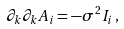<formula> <loc_0><loc_0><loc_500><loc_500>\partial _ { k } \partial _ { k } A _ { i } = - \sigma ^ { 2 } I _ { i } \, ,</formula> 